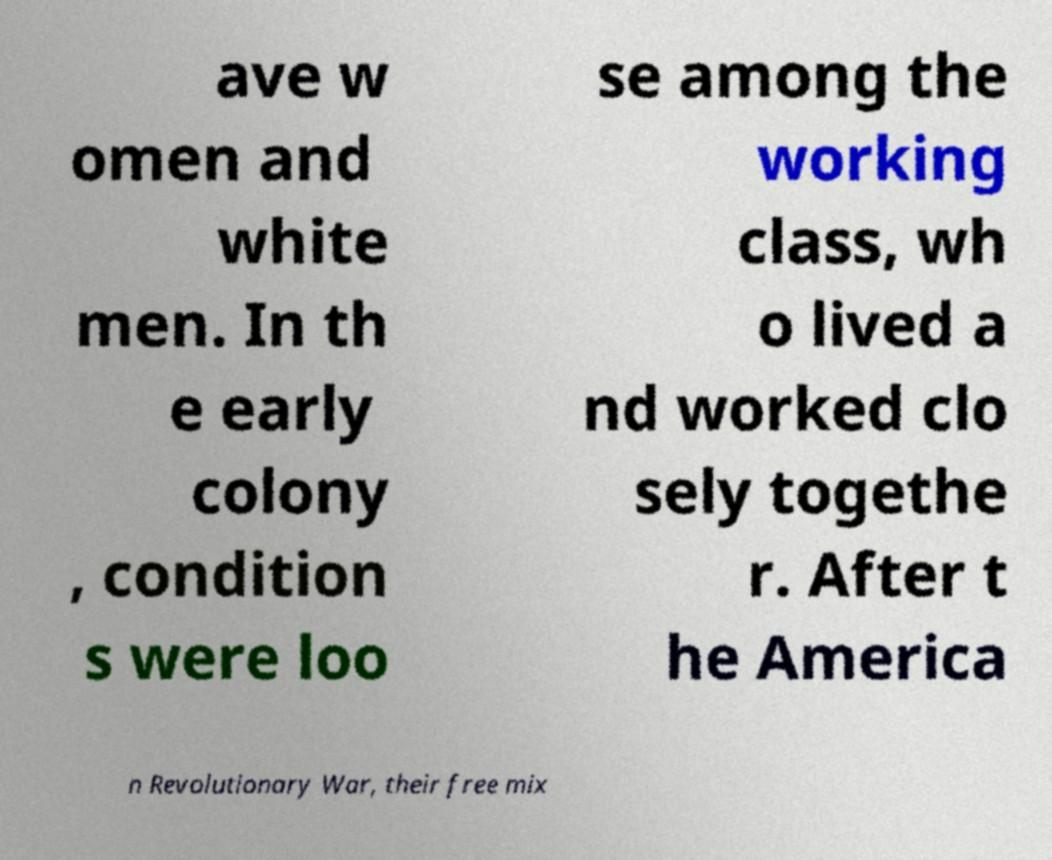Can you read and provide the text displayed in the image?This photo seems to have some interesting text. Can you extract and type it out for me? ave w omen and white men. In th e early colony , condition s were loo se among the working class, wh o lived a nd worked clo sely togethe r. After t he America n Revolutionary War, their free mix 